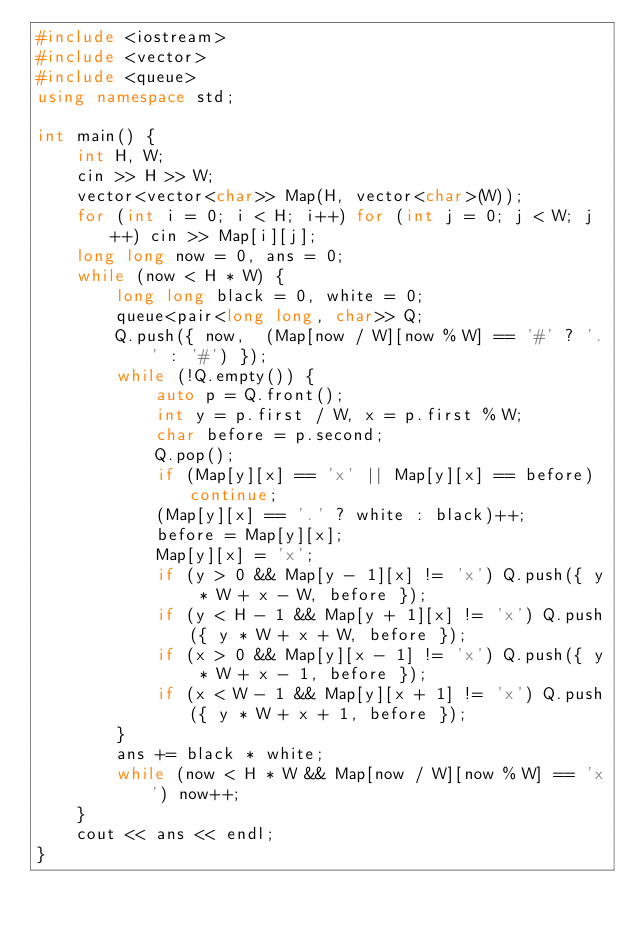<code> <loc_0><loc_0><loc_500><loc_500><_C++_>#include <iostream>
#include <vector>
#include <queue>
using namespace std;

int main() {
	int H, W;
	cin >> H >> W;
	vector<vector<char>> Map(H, vector<char>(W));
	for (int i = 0; i < H; i++) for (int j = 0; j < W; j++) cin >> Map[i][j];
	long long now = 0, ans = 0;
	while (now < H * W) {
		long long black = 0, white = 0;
		queue<pair<long long, char>> Q;
		Q.push({ now,  (Map[now / W][now % W] == '#' ? '.' : '#') });
		while (!Q.empty()) {
			auto p = Q.front();
			int y = p.first / W, x = p.first % W;
			char before = p.second;
			Q.pop();
			if (Map[y][x] == 'x' || Map[y][x] == before) continue;
			(Map[y][x] == '.' ? white : black)++;
			before = Map[y][x];
			Map[y][x] = 'x';
			if (y > 0 && Map[y - 1][x] != 'x') Q.push({ y * W + x - W, before });
			if (y < H - 1 && Map[y + 1][x] != 'x') Q.push({ y * W + x + W, before });
			if (x > 0 && Map[y][x - 1] != 'x') Q.push({ y * W + x - 1, before });
			if (x < W - 1 && Map[y][x + 1] != 'x') Q.push({ y * W + x + 1, before });
		}
		ans += black * white;
		while (now < H * W && Map[now / W][now % W] == 'x') now++;
	}
	cout << ans << endl;
}</code> 